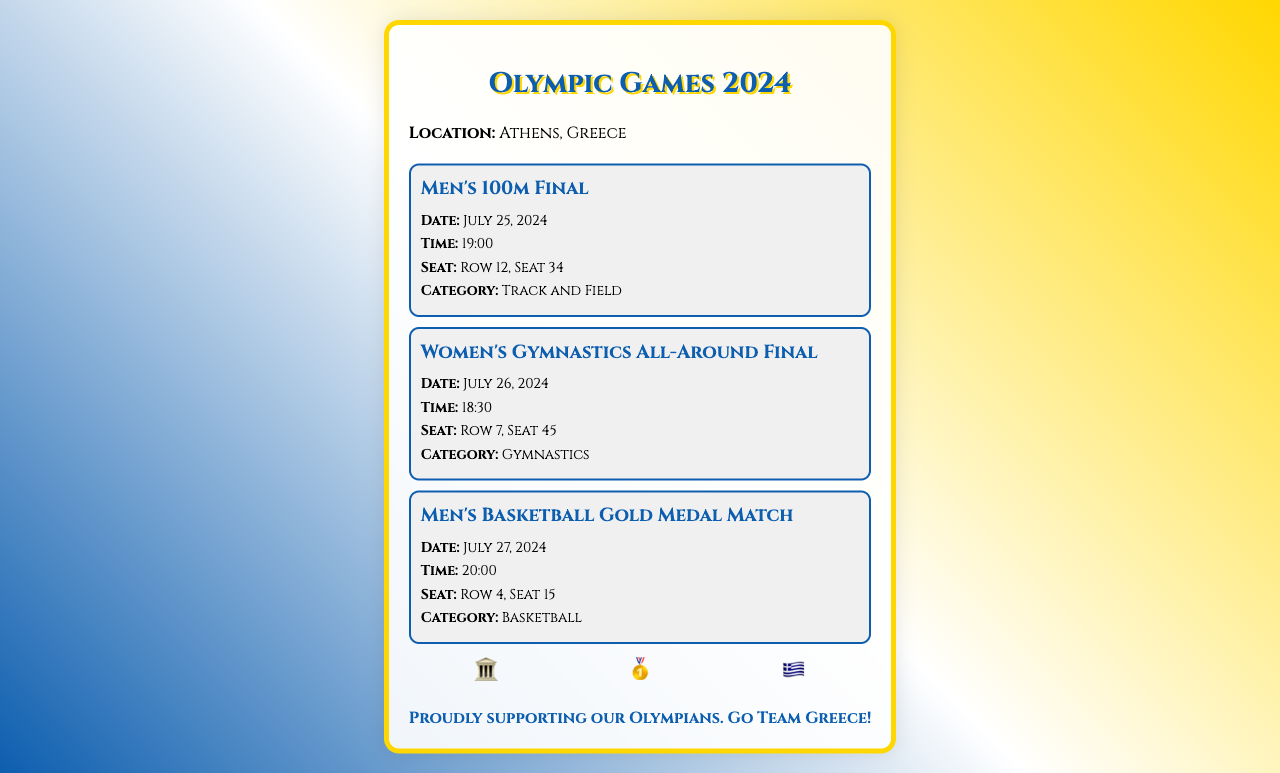What is the location of the Olympic Games? The location of the Olympic Games is stated directly in the document under the location detail.
Answer: Athens, Greece What event is scheduled for July 26, 2024? The document lists events with specific dates, allowing for easy retrieval of the event corresponding to that date.
Answer: Women's Gymnastics All-Around Final What is the seat number for the Men's 100m Final? The seat number is specified in the details of the Men's 100m Final event within the document.
Answer: Row 12, Seat 34 How many events are listed in the document? By counting the event sections within the ticket stub, we see how many events are provided.
Answer: 3 What category does the Men's Basketball Gold Medal Match fall under? The category is mentioned next to the event, categorizing the type of sporting event.
Answer: Basketball What time does the Women's Gymnastics All-Around Final start? The start time is given in the details of the Women's Gymnastics All-Around Final event.
Answer: 18:30 Which symbol is associated with Greek pride in the design? The patriotic design section includes symbols, one of which represents Greek pride specifically.
Answer: 🇬🇷 When is the Men's 100m Final scheduled? The date is provided in the event details for the Men's 100m Final.
Answer: July 25, 2024 What is the footer's message on the ticket stub? The footer at the bottom of the document contains a specific message about supporting Olympians.
Answer: Proudly supporting our Olympians. Go Team Greece! 